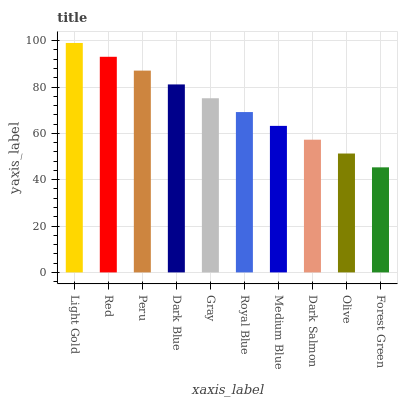Is Forest Green the minimum?
Answer yes or no. Yes. Is Light Gold the maximum?
Answer yes or no. Yes. Is Red the minimum?
Answer yes or no. No. Is Red the maximum?
Answer yes or no. No. Is Light Gold greater than Red?
Answer yes or no. Yes. Is Red less than Light Gold?
Answer yes or no. Yes. Is Red greater than Light Gold?
Answer yes or no. No. Is Light Gold less than Red?
Answer yes or no. No. Is Gray the high median?
Answer yes or no. Yes. Is Royal Blue the low median?
Answer yes or no. Yes. Is Red the high median?
Answer yes or no. No. Is Gray the low median?
Answer yes or no. No. 